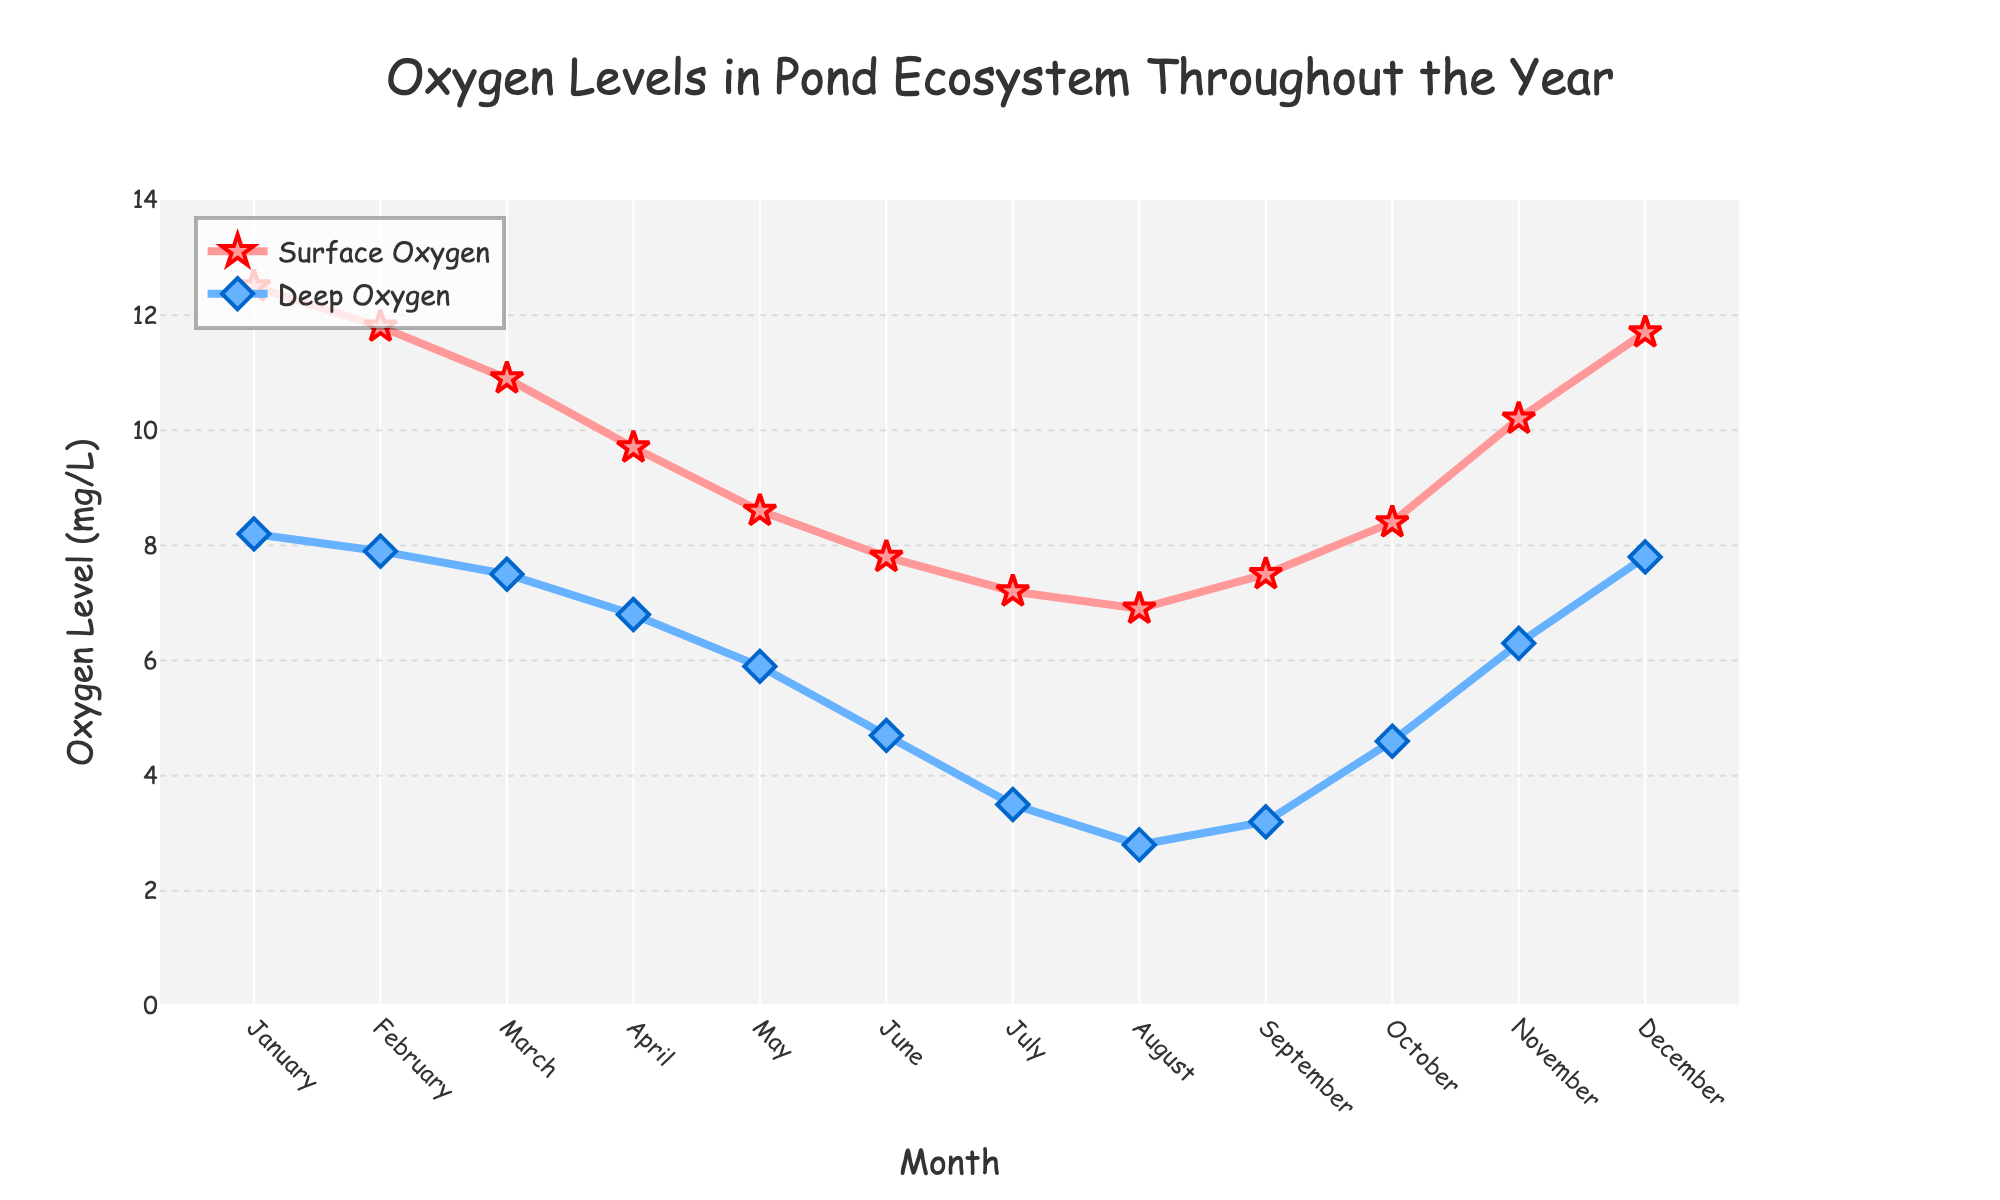Which month shows the highest surface oxygen level? The surface oxygen level line (in red) peaks in January, which is at 12.5 mg/L.
Answer: January During which month does deep water have the lowest oxygen level? By looking at the blue line for deep oxygen levels, the lowest point is in August, at 2.8 mg/L.
Answer: August What is the difference between the surface oxygen and deep oxygen levels in June? In June, the surface oxygen level is 7.8 mg/L and the deep oxygen level is 4.7 mg/L. The difference is 7.8 - 4.7.
Answer: 3.1 Which month shows the closest oxygen levels between the surface and deep water? By comparing the red and blue lines, November shows the closest levels where surface oxygen is 10.2 mg/L and deep oxygen is 6.3 mg/L – the difference being 3.9 mg/L, which seems smallest.
Answer: November How much does the surface oxygen level change from January to July? The surface oxygen level in January is 12.5 mg/L and in July it is 7.2 mg/L. The change is 12.5 - 7.2.
Answer: 5.3 What is the average deep oxygen level in the spring months (March, April, May)? The deep oxygen levels are: March - 7.5 mg/L, April - 6.8 mg/L, May - 5.9 mg/L. The average is (7.5 + 6.8 + 5.9) / 3.
Answer: 6.73 mg/L Which month shows a larger drop in surface oxygen compared to the previous month: April or August? From March to April, the surface oxygen drops from 10.9 to 9.7 mg/L (a drop of 1.2 mg/L). From July to August, it drops from 7.2 to 6.9 mg/L (a drop of 0.3 mg/L).
Answer: April Describe the trend in the oxygen levels from May to August for both surface and deep water. For surface water, the oxygen level decreases from 8.6 in May to 6.9 in August. For deep water, the level decreases from 5.9 in May to 2.8 in August. Both show a downward trend.
Answer: Downward trend for both What is the range of surface oxygen levels throughout the year? The highest surface oxygen level is in January at 12.5 mg/L, and the lowest is in August at 6.9 mg/L. The range is 12.5 - 6.9.
Answer: 5.6 mg/L Compare the oxygen level trend in October for both surface and deep water. In October, both surface and deep oxygen levels increase. Surface oxygen goes from 7.5 in September to 8.4 mg/L, deep oxygen goes from 3.2 in September to 4.6 mg/L.
Answer: Increasing trend for both 